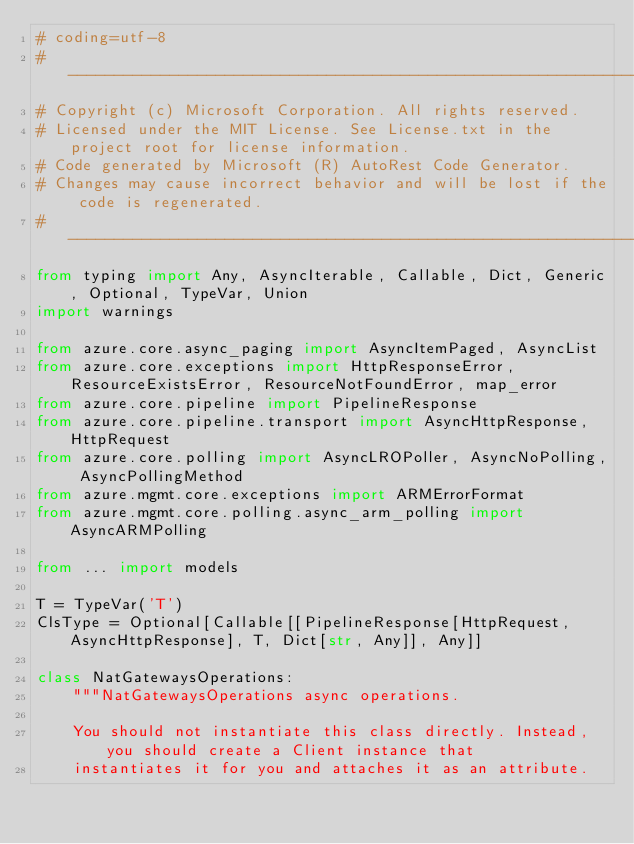<code> <loc_0><loc_0><loc_500><loc_500><_Python_># coding=utf-8
# --------------------------------------------------------------------------
# Copyright (c) Microsoft Corporation. All rights reserved.
# Licensed under the MIT License. See License.txt in the project root for license information.
# Code generated by Microsoft (R) AutoRest Code Generator.
# Changes may cause incorrect behavior and will be lost if the code is regenerated.
# --------------------------------------------------------------------------
from typing import Any, AsyncIterable, Callable, Dict, Generic, Optional, TypeVar, Union
import warnings

from azure.core.async_paging import AsyncItemPaged, AsyncList
from azure.core.exceptions import HttpResponseError, ResourceExistsError, ResourceNotFoundError, map_error
from azure.core.pipeline import PipelineResponse
from azure.core.pipeline.transport import AsyncHttpResponse, HttpRequest
from azure.core.polling import AsyncLROPoller, AsyncNoPolling, AsyncPollingMethod
from azure.mgmt.core.exceptions import ARMErrorFormat
from azure.mgmt.core.polling.async_arm_polling import AsyncARMPolling

from ... import models

T = TypeVar('T')
ClsType = Optional[Callable[[PipelineResponse[HttpRequest, AsyncHttpResponse], T, Dict[str, Any]], Any]]

class NatGatewaysOperations:
    """NatGatewaysOperations async operations.

    You should not instantiate this class directly. Instead, you should create a Client instance that
    instantiates it for you and attaches it as an attribute.
</code> 